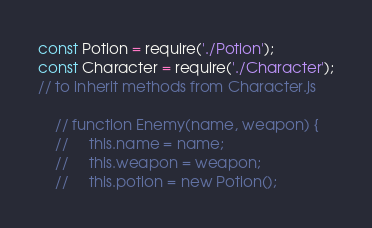Convert code to text. <code><loc_0><loc_0><loc_500><loc_500><_JavaScript_>const Potion = require('./Potion');
const Character = require('./Character');
// to inherit methods from Character.js

    // function Enemy(name, weapon) {
    //     this.name = name;
    //     this.weapon = weapon;
    //     this.potion = new Potion();
</code> 